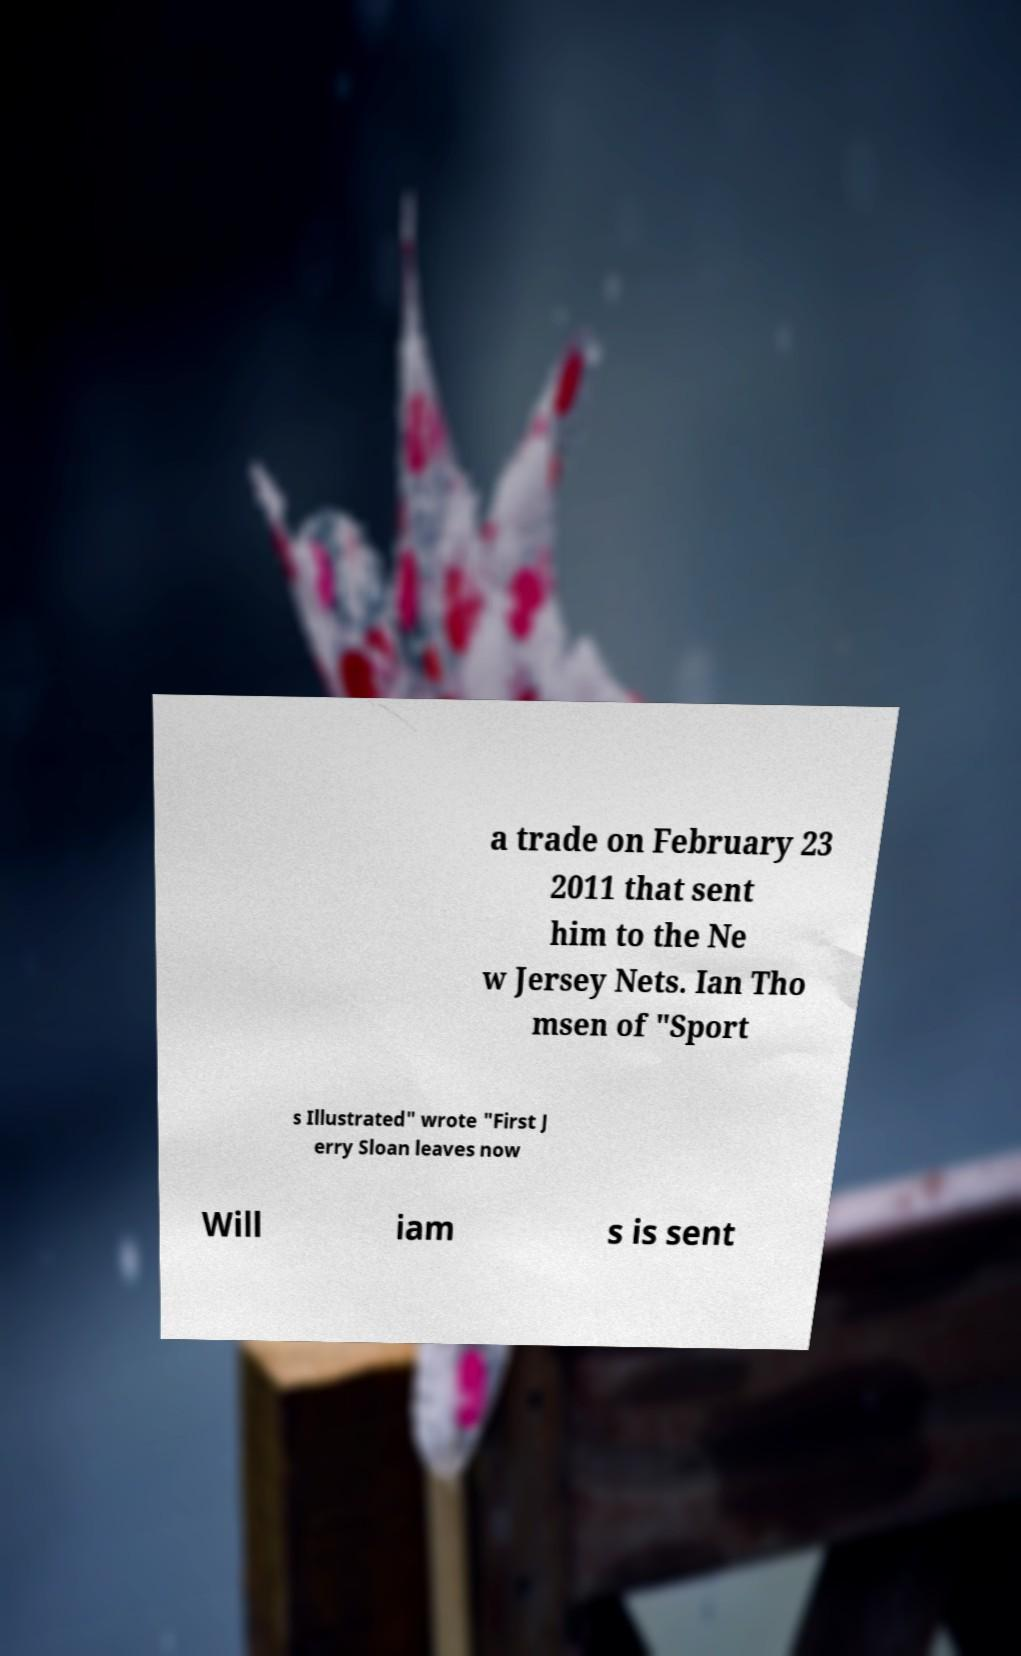Can you accurately transcribe the text from the provided image for me? a trade on February 23 2011 that sent him to the Ne w Jersey Nets. Ian Tho msen of "Sport s Illustrated" wrote "First J erry Sloan leaves now Will iam s is sent 